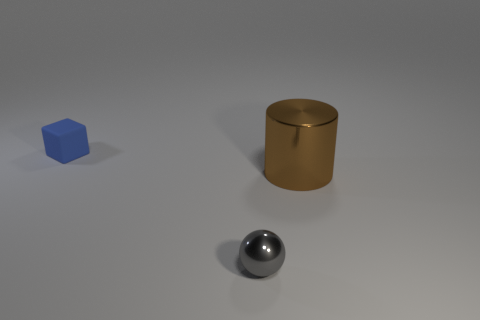Add 2 green rubber objects. How many objects exist? 5 Subtract all spheres. How many objects are left? 2 Subtract all brown metal cylinders. Subtract all big metallic cylinders. How many objects are left? 1 Add 1 matte objects. How many matte objects are left? 2 Add 2 large purple objects. How many large purple objects exist? 2 Subtract 0 brown balls. How many objects are left? 3 